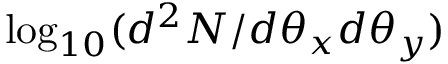Convert formula to latex. <formula><loc_0><loc_0><loc_500><loc_500>\log _ { 1 0 } ( d ^ { 2 } N / d \theta _ { x } d \theta _ { y } )</formula> 